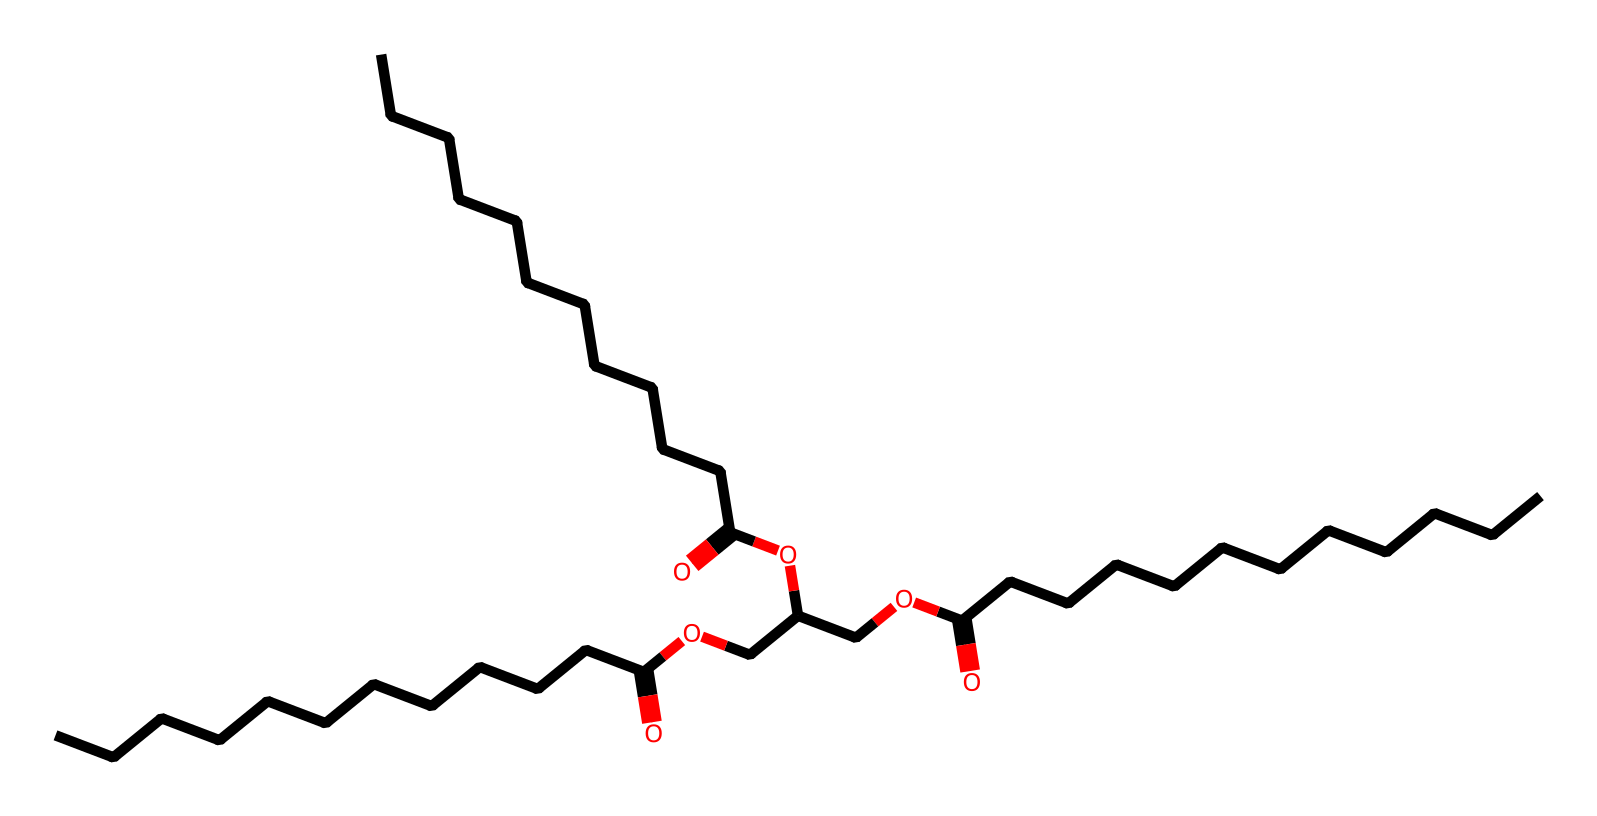What is the primary functional group in this chemical structure? The chemical contains a carboxylic acid functional group, which is identified by the presence of the -COOH group in the structure. This group provides the compound's acidic properties.
Answer: carboxylic acid How many carbon atoms are present in this molecule? By analyzing the SMILES representation, we can count a total of 27 carbon atoms indicated by the arrangement of 'C's throughout the structure.
Answer: 27 What type of chemical is this lubricants? The presence of ester bonds (indicated by the -COO- groups connecting carbon chains) suggests this molecule is an ester, which is common in lubricants due to their smooth texture and ability to reduce friction.
Answer: ester What is the total number of oxygen atoms in this molecule? The structure shows 6 distinct oxygen atoms: 4 in the ester functional groups (-COO-) and 2 in the carboxylic acid groups (-COOH).
Answer: 6 What is the likely source of the fatty acids in this biodegradable lubricant? The long chains of carbon can be attributed to fatty acids, which usually come from natural oils and fats, such as vegetable oils. The long carbon chains of fatty acids contribute to the lubricating properties.
Answer: vegetable oils What effect do the ester bonds have on the properties of this lubricant? Ester bonds lower the intermolecular forces between molecules, resulting in a lubricant that has good flow and better resistance to breakdown, which is ideal for garden tools experiencing friction.
Answer: good flow How do biodegradable lubricants like this one benefit the environment? These lubricants decompose naturally through microbial action, reducing pollution and ecological harm compared to conventional lubricants that can persist in the environment.
Answer: reduced pollution 